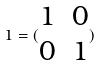<formula> <loc_0><loc_0><loc_500><loc_500>1 = ( \begin{matrix} 1 & 0 \\ 0 & 1 \end{matrix} )</formula> 